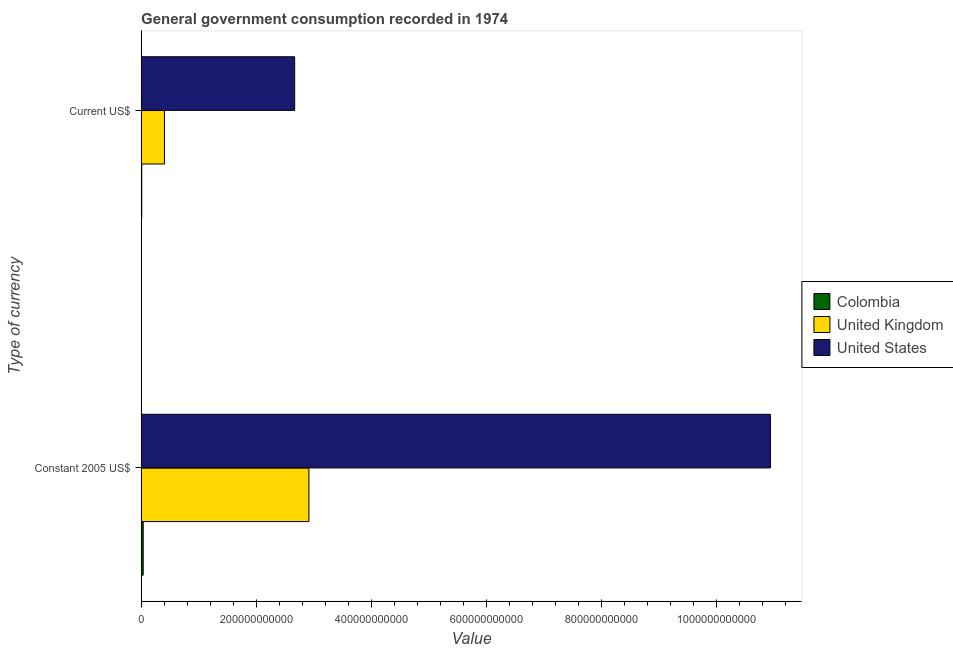How many different coloured bars are there?
Make the answer very short. 3. How many groups of bars are there?
Offer a terse response. 2. Are the number of bars per tick equal to the number of legend labels?
Give a very brief answer. Yes. How many bars are there on the 2nd tick from the top?
Your response must be concise. 3. How many bars are there on the 1st tick from the bottom?
Offer a very short reply. 3. What is the label of the 2nd group of bars from the top?
Provide a short and direct response. Constant 2005 US$. What is the value consumed in constant 2005 us$ in United Kingdom?
Your response must be concise. 2.92e+11. Across all countries, what is the maximum value consumed in constant 2005 us$?
Your answer should be very brief. 1.09e+12. Across all countries, what is the minimum value consumed in constant 2005 us$?
Give a very brief answer. 3.61e+09. In which country was the value consumed in constant 2005 us$ maximum?
Your response must be concise. United States. What is the total value consumed in current us$ in the graph?
Your answer should be very brief. 3.09e+11. What is the difference between the value consumed in current us$ in Colombia and that in United Kingdom?
Ensure brevity in your answer.  -3.94e+1. What is the difference between the value consumed in current us$ in United States and the value consumed in constant 2005 us$ in Colombia?
Your answer should be very brief. 2.63e+11. What is the average value consumed in constant 2005 us$ per country?
Your answer should be compact. 4.63e+11. What is the difference between the value consumed in current us$ and value consumed in constant 2005 us$ in United States?
Your response must be concise. -8.27e+11. What is the ratio of the value consumed in current us$ in United States to that in United Kingdom?
Your response must be concise. 6.59. What does the 3rd bar from the bottom in Current US$ represents?
Keep it short and to the point. United States. What is the difference between two consecutive major ticks on the X-axis?
Provide a short and direct response. 2.00e+11. Are the values on the major ticks of X-axis written in scientific E-notation?
Offer a very short reply. No. Does the graph contain any zero values?
Your response must be concise. No. How many legend labels are there?
Give a very brief answer. 3. How are the legend labels stacked?
Offer a very short reply. Vertical. What is the title of the graph?
Keep it short and to the point. General government consumption recorded in 1974. What is the label or title of the X-axis?
Provide a succinct answer. Value. What is the label or title of the Y-axis?
Ensure brevity in your answer.  Type of currency. What is the Value in Colombia in Constant 2005 US$?
Ensure brevity in your answer.  3.61e+09. What is the Value in United Kingdom in Constant 2005 US$?
Keep it short and to the point. 2.92e+11. What is the Value of United States in Constant 2005 US$?
Offer a very short reply. 1.09e+12. What is the Value in Colombia in Current US$?
Your response must be concise. 1.07e+09. What is the Value of United Kingdom in Current US$?
Provide a succinct answer. 4.05e+1. What is the Value in United States in Current US$?
Ensure brevity in your answer.  2.67e+11. Across all Type of currency, what is the maximum Value of Colombia?
Ensure brevity in your answer.  3.61e+09. Across all Type of currency, what is the maximum Value of United Kingdom?
Ensure brevity in your answer.  2.92e+11. Across all Type of currency, what is the maximum Value in United States?
Ensure brevity in your answer.  1.09e+12. Across all Type of currency, what is the minimum Value of Colombia?
Make the answer very short. 1.07e+09. Across all Type of currency, what is the minimum Value in United Kingdom?
Keep it short and to the point. 4.05e+1. Across all Type of currency, what is the minimum Value in United States?
Your answer should be compact. 2.67e+11. What is the total Value in Colombia in the graph?
Give a very brief answer. 4.68e+09. What is the total Value in United Kingdom in the graph?
Provide a succinct answer. 3.32e+11. What is the total Value in United States in the graph?
Offer a terse response. 1.36e+12. What is the difference between the Value in Colombia in Constant 2005 US$ and that in Current US$?
Offer a very short reply. 2.53e+09. What is the difference between the Value of United Kingdom in Constant 2005 US$ and that in Current US$?
Make the answer very short. 2.51e+11. What is the difference between the Value in United States in Constant 2005 US$ and that in Current US$?
Your answer should be compact. 8.27e+11. What is the difference between the Value of Colombia in Constant 2005 US$ and the Value of United Kingdom in Current US$?
Your answer should be very brief. -3.69e+1. What is the difference between the Value in Colombia in Constant 2005 US$ and the Value in United States in Current US$?
Provide a short and direct response. -2.63e+11. What is the difference between the Value of United Kingdom in Constant 2005 US$ and the Value of United States in Current US$?
Make the answer very short. 2.48e+1. What is the average Value of Colombia per Type of currency?
Give a very brief answer. 2.34e+09. What is the average Value in United Kingdom per Type of currency?
Your response must be concise. 1.66e+11. What is the average Value of United States per Type of currency?
Ensure brevity in your answer.  6.81e+11. What is the difference between the Value in Colombia and Value in United Kingdom in Constant 2005 US$?
Your answer should be compact. -2.88e+11. What is the difference between the Value in Colombia and Value in United States in Constant 2005 US$?
Make the answer very short. -1.09e+12. What is the difference between the Value in United Kingdom and Value in United States in Constant 2005 US$?
Your answer should be compact. -8.02e+11. What is the difference between the Value in Colombia and Value in United Kingdom in Current US$?
Give a very brief answer. -3.94e+1. What is the difference between the Value of Colombia and Value of United States in Current US$?
Offer a very short reply. -2.66e+11. What is the difference between the Value in United Kingdom and Value in United States in Current US$?
Your answer should be compact. -2.26e+11. What is the ratio of the Value in Colombia in Constant 2005 US$ to that in Current US$?
Your answer should be very brief. 3.36. What is the ratio of the Value of United Kingdom in Constant 2005 US$ to that in Current US$?
Make the answer very short. 7.2. What is the ratio of the Value in United States in Constant 2005 US$ to that in Current US$?
Provide a short and direct response. 4.1. What is the difference between the highest and the second highest Value of Colombia?
Your answer should be very brief. 2.53e+09. What is the difference between the highest and the second highest Value in United Kingdom?
Make the answer very short. 2.51e+11. What is the difference between the highest and the second highest Value of United States?
Provide a short and direct response. 8.27e+11. What is the difference between the highest and the lowest Value of Colombia?
Provide a succinct answer. 2.53e+09. What is the difference between the highest and the lowest Value in United Kingdom?
Give a very brief answer. 2.51e+11. What is the difference between the highest and the lowest Value of United States?
Your response must be concise. 8.27e+11. 